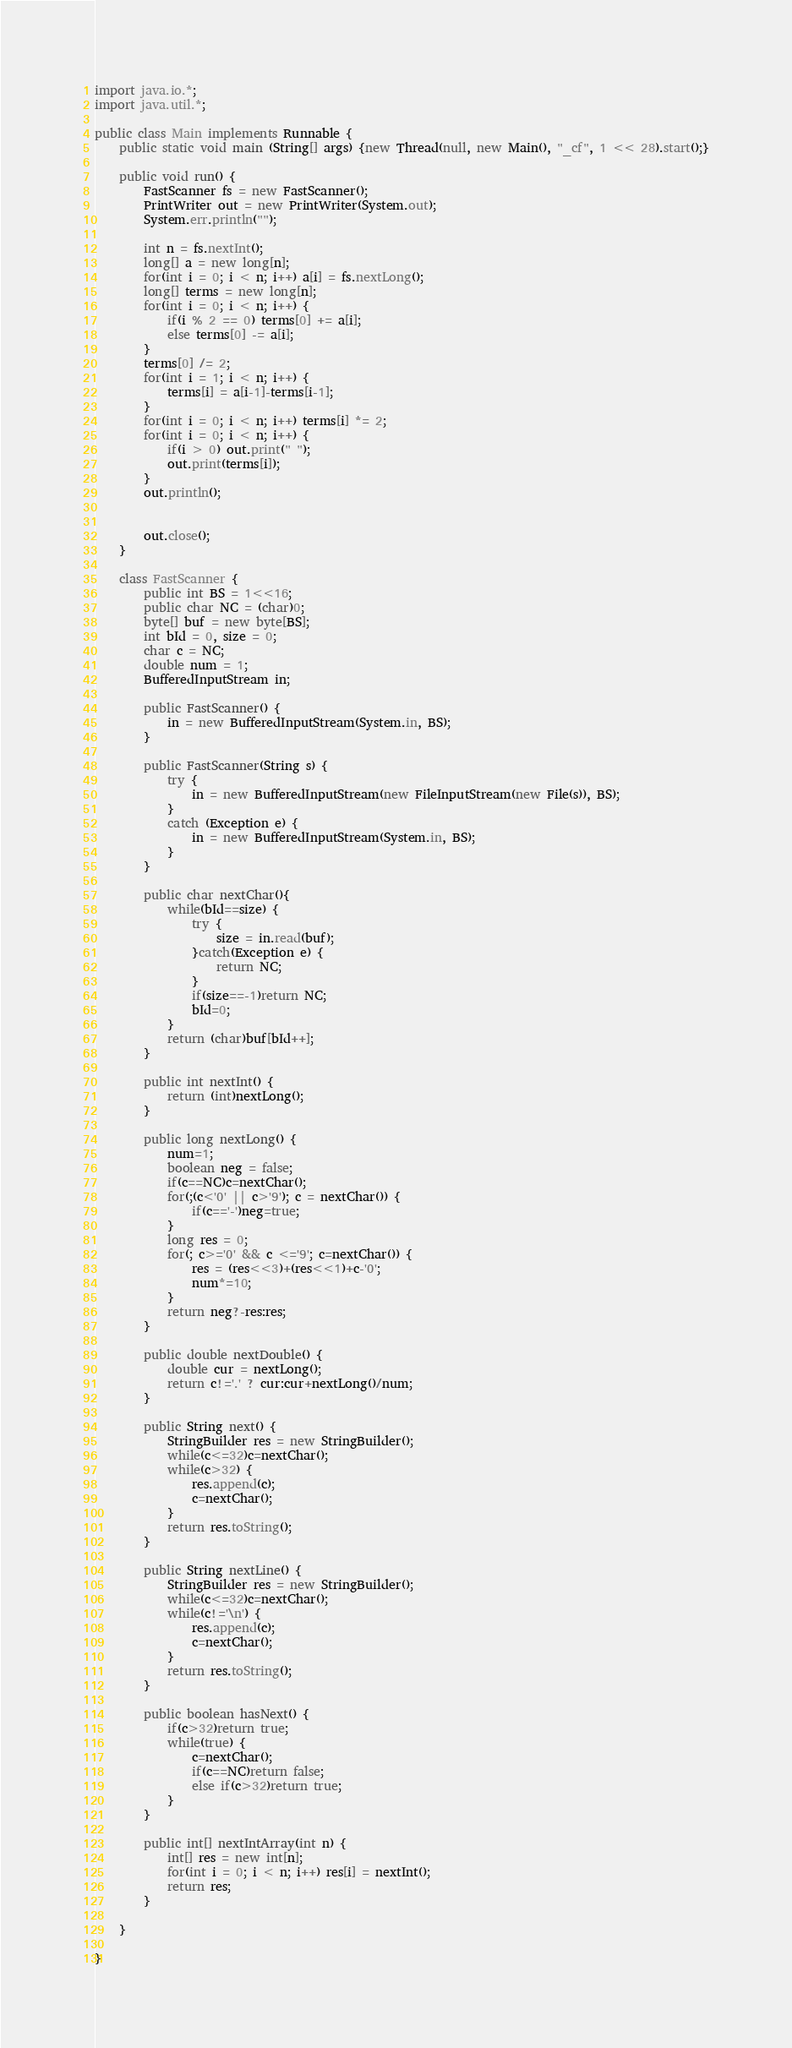<code> <loc_0><loc_0><loc_500><loc_500><_Java_>import java.io.*;
import java.util.*;

public class Main implements Runnable {
	public static void main (String[] args) {new Thread(null, new Main(), "_cf", 1 << 28).start();}

	public void run() {
		FastScanner fs = new FastScanner();
		PrintWriter out = new PrintWriter(System.out);
		System.err.println("");

		int n = fs.nextInt();
		long[] a = new long[n];
		for(int i = 0; i < n; i++) a[i] = fs.nextLong();
		long[] terms = new long[n];
		for(int i = 0; i < n; i++) {
			if(i % 2 == 0) terms[0] += a[i];
			else terms[0] -= a[i];
		}
		terms[0] /= 2;
		for(int i = 1; i < n; i++) {
			terms[i] = a[i-1]-terms[i-1];
		}
		for(int i = 0; i < n; i++) terms[i] *= 2;
		for(int i = 0; i < n; i++) {
			if(i > 0) out.print(" ");
			out.print(terms[i]);
		}
		out.println();
		
		
		out.close();
	}

	class FastScanner {
		public int BS = 1<<16;
		public char NC = (char)0;
		byte[] buf = new byte[BS];
		int bId = 0, size = 0;
		char c = NC;
		double num = 1;
		BufferedInputStream in;

		public FastScanner() {
			in = new BufferedInputStream(System.in, BS);
		}

		public FastScanner(String s) {
			try {
				in = new BufferedInputStream(new FileInputStream(new File(s)), BS);
			}
			catch (Exception e) {
				in = new BufferedInputStream(System.in, BS);
			}
		}

		public char nextChar(){
			while(bId==size) {
				try {
					size = in.read(buf);
				}catch(Exception e) {
					return NC;
				}                
				if(size==-1)return NC;
				bId=0;
			}
			return (char)buf[bId++];
		}

		public int nextInt() {
			return (int)nextLong();
		}

		public long nextLong() {
			num=1;
			boolean neg = false;
			if(c==NC)c=nextChar();
			for(;(c<'0' || c>'9'); c = nextChar()) {
				if(c=='-')neg=true;
			}
			long res = 0;
			for(; c>='0' && c <='9'; c=nextChar()) {
				res = (res<<3)+(res<<1)+c-'0';
				num*=10;
			}
			return neg?-res:res;
		}

		public double nextDouble() {
			double cur = nextLong();
			return c!='.' ? cur:cur+nextLong()/num;
		}

		public String next() {
			StringBuilder res = new StringBuilder();
			while(c<=32)c=nextChar();
			while(c>32) {
				res.append(c);
				c=nextChar();
			}
			return res.toString();
		}

		public String nextLine() {
			StringBuilder res = new StringBuilder();
			while(c<=32)c=nextChar();
			while(c!='\n') {
				res.append(c);
				c=nextChar();
			}
			return res.toString();
		}

		public boolean hasNext() {
			if(c>32)return true;
			while(true) {
				c=nextChar();
				if(c==NC)return false;
				else if(c>32)return true;
			}
		}
		
		public int[] nextIntArray(int n) {
			int[] res = new int[n];
			for(int i = 0; i < n; i++) res[i] = nextInt();
			return res;
		}
		
	}

}</code> 